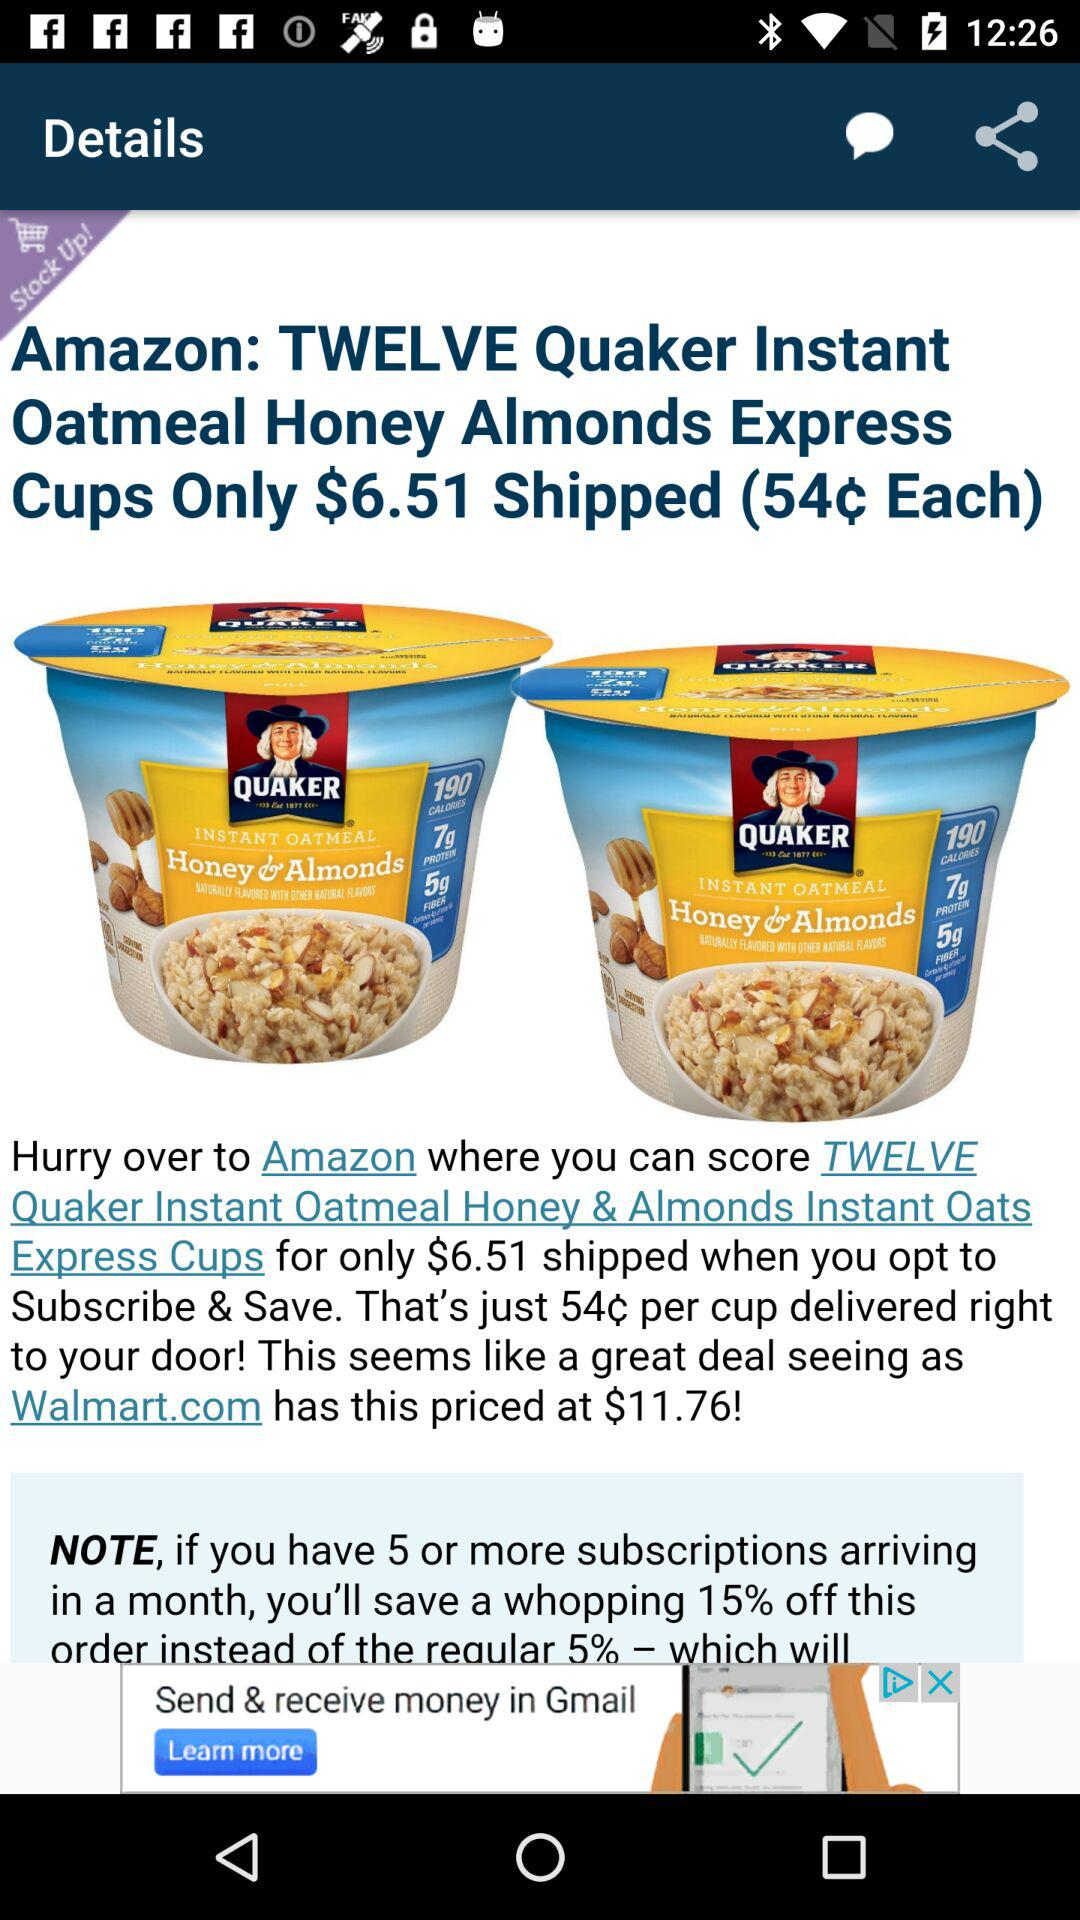What is the price of the cups on Amazon? The price of the cups is $6.51. 